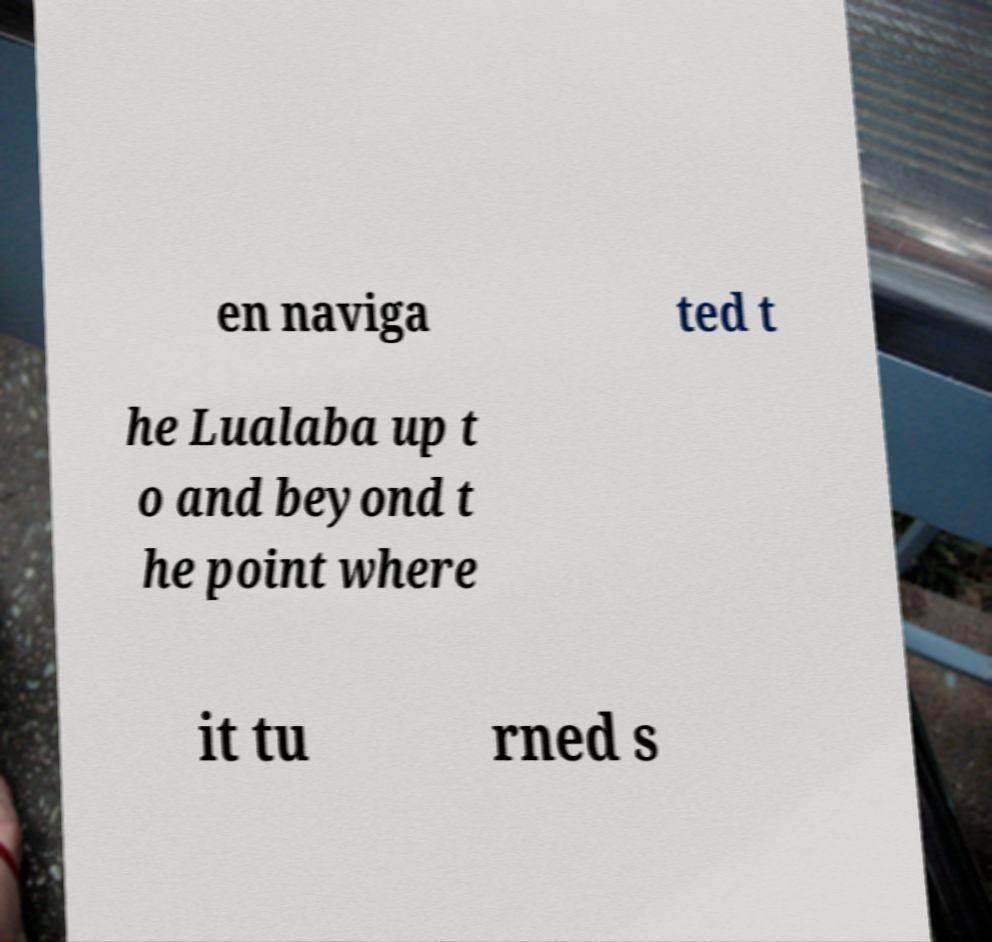Please read and relay the text visible in this image. What does it say? en naviga ted t he Lualaba up t o and beyond t he point where it tu rned s 